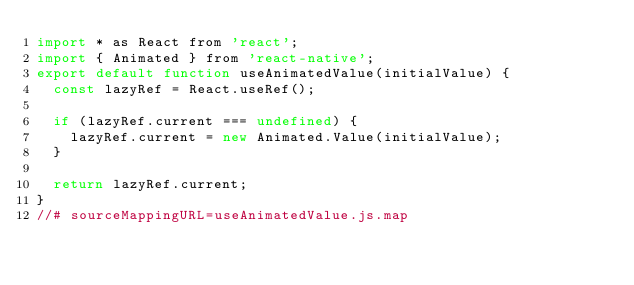<code> <loc_0><loc_0><loc_500><loc_500><_JavaScript_>import * as React from 'react';
import { Animated } from 'react-native';
export default function useAnimatedValue(initialValue) {
  const lazyRef = React.useRef();

  if (lazyRef.current === undefined) {
    lazyRef.current = new Animated.Value(initialValue);
  }

  return lazyRef.current;
}
//# sourceMappingURL=useAnimatedValue.js.map</code> 